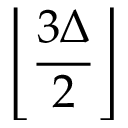Convert formula to latex. <formula><loc_0><loc_0><loc_500><loc_500>\left \lfloor { \frac { 3 \Delta } { 2 } } \right \rfloor</formula> 